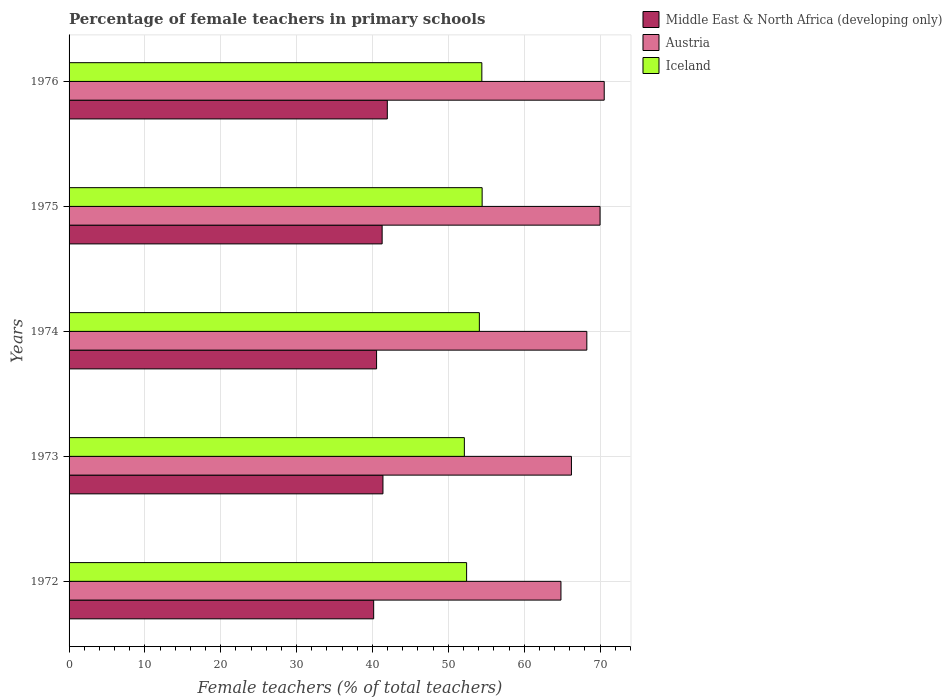How many different coloured bars are there?
Ensure brevity in your answer.  3. Are the number of bars on each tick of the Y-axis equal?
Keep it short and to the point. Yes. How many bars are there on the 1st tick from the top?
Provide a short and direct response. 3. What is the label of the 3rd group of bars from the top?
Offer a very short reply. 1974. What is the percentage of female teachers in Austria in 1976?
Keep it short and to the point. 70.55. Across all years, what is the maximum percentage of female teachers in Middle East & North Africa (developing only)?
Offer a terse response. 41.96. Across all years, what is the minimum percentage of female teachers in Iceland?
Give a very brief answer. 52.11. In which year was the percentage of female teachers in Iceland maximum?
Your answer should be compact. 1975. What is the total percentage of female teachers in Iceland in the graph?
Provide a short and direct response. 267.5. What is the difference between the percentage of female teachers in Austria in 1974 and that in 1975?
Provide a short and direct response. -1.74. What is the difference between the percentage of female teachers in Middle East & North Africa (developing only) in 1976 and the percentage of female teachers in Iceland in 1972?
Give a very brief answer. -10.45. What is the average percentage of female teachers in Austria per year?
Your answer should be very brief. 67.98. In the year 1976, what is the difference between the percentage of female teachers in Austria and percentage of female teachers in Iceland?
Make the answer very short. 16.13. In how many years, is the percentage of female teachers in Iceland greater than 12 %?
Give a very brief answer. 5. What is the ratio of the percentage of female teachers in Middle East & North Africa (developing only) in 1972 to that in 1974?
Give a very brief answer. 0.99. Is the percentage of female teachers in Iceland in 1972 less than that in 1974?
Offer a terse response. Yes. Is the difference between the percentage of female teachers in Austria in 1973 and 1975 greater than the difference between the percentage of female teachers in Iceland in 1973 and 1975?
Provide a succinct answer. No. What is the difference between the highest and the second highest percentage of female teachers in Middle East & North Africa (developing only)?
Keep it short and to the point. 0.57. What is the difference between the highest and the lowest percentage of female teachers in Austria?
Give a very brief answer. 5.7. In how many years, is the percentage of female teachers in Iceland greater than the average percentage of female teachers in Iceland taken over all years?
Make the answer very short. 3. Is the sum of the percentage of female teachers in Middle East & North Africa (developing only) in 1972 and 1976 greater than the maximum percentage of female teachers in Iceland across all years?
Your answer should be very brief. Yes. What does the 3rd bar from the top in 1974 represents?
Your answer should be compact. Middle East & North Africa (developing only). What does the 2nd bar from the bottom in 1972 represents?
Your answer should be compact. Austria. How many bars are there?
Offer a terse response. 15. What is the difference between two consecutive major ticks on the X-axis?
Your answer should be very brief. 10. Are the values on the major ticks of X-axis written in scientific E-notation?
Your answer should be compact. No. Where does the legend appear in the graph?
Give a very brief answer. Top right. What is the title of the graph?
Offer a very short reply. Percentage of female teachers in primary schools. What is the label or title of the X-axis?
Make the answer very short. Female teachers (% of total teachers). What is the Female teachers (% of total teachers) of Middle East & North Africa (developing only) in 1972?
Your response must be concise. 40.16. What is the Female teachers (% of total teachers) of Austria in 1972?
Offer a terse response. 64.85. What is the Female teachers (% of total teachers) in Iceland in 1972?
Ensure brevity in your answer.  52.41. What is the Female teachers (% of total teachers) of Middle East & North Africa (developing only) in 1973?
Keep it short and to the point. 41.38. What is the Female teachers (% of total teachers) in Austria in 1973?
Your answer should be compact. 66.23. What is the Female teachers (% of total teachers) of Iceland in 1973?
Provide a short and direct response. 52.11. What is the Female teachers (% of total teachers) in Middle East & North Africa (developing only) in 1974?
Offer a very short reply. 40.54. What is the Female teachers (% of total teachers) in Austria in 1974?
Give a very brief answer. 68.26. What is the Female teachers (% of total teachers) of Iceland in 1974?
Provide a short and direct response. 54.09. What is the Female teachers (% of total teachers) of Middle East & North Africa (developing only) in 1975?
Provide a succinct answer. 41.28. What is the Female teachers (% of total teachers) in Austria in 1975?
Offer a terse response. 70.01. What is the Female teachers (% of total teachers) of Iceland in 1975?
Your answer should be compact. 54.46. What is the Female teachers (% of total teachers) of Middle East & North Africa (developing only) in 1976?
Your response must be concise. 41.96. What is the Female teachers (% of total teachers) in Austria in 1976?
Make the answer very short. 70.55. What is the Female teachers (% of total teachers) of Iceland in 1976?
Ensure brevity in your answer.  54.42. Across all years, what is the maximum Female teachers (% of total teachers) in Middle East & North Africa (developing only)?
Offer a terse response. 41.96. Across all years, what is the maximum Female teachers (% of total teachers) in Austria?
Give a very brief answer. 70.55. Across all years, what is the maximum Female teachers (% of total teachers) in Iceland?
Your response must be concise. 54.46. Across all years, what is the minimum Female teachers (% of total teachers) of Middle East & North Africa (developing only)?
Your answer should be compact. 40.16. Across all years, what is the minimum Female teachers (% of total teachers) of Austria?
Ensure brevity in your answer.  64.85. Across all years, what is the minimum Female teachers (% of total teachers) of Iceland?
Ensure brevity in your answer.  52.11. What is the total Female teachers (% of total teachers) in Middle East & North Africa (developing only) in the graph?
Keep it short and to the point. 205.31. What is the total Female teachers (% of total teachers) of Austria in the graph?
Make the answer very short. 339.91. What is the total Female teachers (% of total teachers) in Iceland in the graph?
Provide a short and direct response. 267.5. What is the difference between the Female teachers (% of total teachers) of Middle East & North Africa (developing only) in 1972 and that in 1973?
Ensure brevity in your answer.  -1.22. What is the difference between the Female teachers (% of total teachers) of Austria in 1972 and that in 1973?
Keep it short and to the point. -1.38. What is the difference between the Female teachers (% of total teachers) of Iceland in 1972 and that in 1973?
Offer a very short reply. 0.3. What is the difference between the Female teachers (% of total teachers) of Middle East & North Africa (developing only) in 1972 and that in 1974?
Provide a succinct answer. -0.38. What is the difference between the Female teachers (% of total teachers) of Austria in 1972 and that in 1974?
Give a very brief answer. -3.41. What is the difference between the Female teachers (% of total teachers) of Iceland in 1972 and that in 1974?
Your response must be concise. -1.68. What is the difference between the Female teachers (% of total teachers) in Middle East & North Africa (developing only) in 1972 and that in 1975?
Offer a very short reply. -1.12. What is the difference between the Female teachers (% of total teachers) in Austria in 1972 and that in 1975?
Offer a terse response. -5.15. What is the difference between the Female teachers (% of total teachers) in Iceland in 1972 and that in 1975?
Ensure brevity in your answer.  -2.05. What is the difference between the Female teachers (% of total teachers) of Middle East & North Africa (developing only) in 1972 and that in 1976?
Ensure brevity in your answer.  -1.8. What is the difference between the Female teachers (% of total teachers) in Austria in 1972 and that in 1976?
Offer a very short reply. -5.7. What is the difference between the Female teachers (% of total teachers) of Iceland in 1972 and that in 1976?
Offer a terse response. -2.01. What is the difference between the Female teachers (% of total teachers) of Middle East & North Africa (developing only) in 1973 and that in 1974?
Offer a terse response. 0.84. What is the difference between the Female teachers (% of total teachers) of Austria in 1973 and that in 1974?
Offer a very short reply. -2.03. What is the difference between the Female teachers (% of total teachers) of Iceland in 1973 and that in 1974?
Your response must be concise. -1.98. What is the difference between the Female teachers (% of total teachers) in Middle East & North Africa (developing only) in 1973 and that in 1975?
Ensure brevity in your answer.  0.11. What is the difference between the Female teachers (% of total teachers) of Austria in 1973 and that in 1975?
Provide a succinct answer. -3.77. What is the difference between the Female teachers (% of total teachers) in Iceland in 1973 and that in 1975?
Your answer should be compact. -2.35. What is the difference between the Female teachers (% of total teachers) of Middle East & North Africa (developing only) in 1973 and that in 1976?
Ensure brevity in your answer.  -0.57. What is the difference between the Female teachers (% of total teachers) in Austria in 1973 and that in 1976?
Provide a short and direct response. -4.32. What is the difference between the Female teachers (% of total teachers) in Iceland in 1973 and that in 1976?
Your answer should be very brief. -2.31. What is the difference between the Female teachers (% of total teachers) in Middle East & North Africa (developing only) in 1974 and that in 1975?
Make the answer very short. -0.73. What is the difference between the Female teachers (% of total teachers) in Austria in 1974 and that in 1975?
Make the answer very short. -1.74. What is the difference between the Female teachers (% of total teachers) of Iceland in 1974 and that in 1975?
Offer a very short reply. -0.37. What is the difference between the Female teachers (% of total teachers) of Middle East & North Africa (developing only) in 1974 and that in 1976?
Provide a succinct answer. -1.42. What is the difference between the Female teachers (% of total teachers) in Austria in 1974 and that in 1976?
Provide a short and direct response. -2.29. What is the difference between the Female teachers (% of total teachers) of Iceland in 1974 and that in 1976?
Your answer should be compact. -0.33. What is the difference between the Female teachers (% of total teachers) of Middle East & North Africa (developing only) in 1975 and that in 1976?
Offer a very short reply. -0.68. What is the difference between the Female teachers (% of total teachers) of Austria in 1975 and that in 1976?
Make the answer very short. -0.55. What is the difference between the Female teachers (% of total teachers) in Iceland in 1975 and that in 1976?
Offer a terse response. 0.04. What is the difference between the Female teachers (% of total teachers) of Middle East & North Africa (developing only) in 1972 and the Female teachers (% of total teachers) of Austria in 1973?
Provide a short and direct response. -26.07. What is the difference between the Female teachers (% of total teachers) of Middle East & North Africa (developing only) in 1972 and the Female teachers (% of total teachers) of Iceland in 1973?
Your response must be concise. -11.96. What is the difference between the Female teachers (% of total teachers) in Austria in 1972 and the Female teachers (% of total teachers) in Iceland in 1973?
Your answer should be compact. 12.74. What is the difference between the Female teachers (% of total teachers) of Middle East & North Africa (developing only) in 1972 and the Female teachers (% of total teachers) of Austria in 1974?
Ensure brevity in your answer.  -28.1. What is the difference between the Female teachers (% of total teachers) in Middle East & North Africa (developing only) in 1972 and the Female teachers (% of total teachers) in Iceland in 1974?
Provide a short and direct response. -13.93. What is the difference between the Female teachers (% of total teachers) of Austria in 1972 and the Female teachers (% of total teachers) of Iceland in 1974?
Your answer should be very brief. 10.76. What is the difference between the Female teachers (% of total teachers) in Middle East & North Africa (developing only) in 1972 and the Female teachers (% of total teachers) in Austria in 1975?
Provide a succinct answer. -29.85. What is the difference between the Female teachers (% of total teachers) in Middle East & North Africa (developing only) in 1972 and the Female teachers (% of total teachers) in Iceland in 1975?
Your answer should be compact. -14.3. What is the difference between the Female teachers (% of total teachers) of Austria in 1972 and the Female teachers (% of total teachers) of Iceland in 1975?
Ensure brevity in your answer.  10.39. What is the difference between the Female teachers (% of total teachers) of Middle East & North Africa (developing only) in 1972 and the Female teachers (% of total teachers) of Austria in 1976?
Keep it short and to the point. -30.39. What is the difference between the Female teachers (% of total teachers) of Middle East & North Africa (developing only) in 1972 and the Female teachers (% of total teachers) of Iceland in 1976?
Offer a very short reply. -14.26. What is the difference between the Female teachers (% of total teachers) in Austria in 1972 and the Female teachers (% of total teachers) in Iceland in 1976?
Offer a terse response. 10.43. What is the difference between the Female teachers (% of total teachers) in Middle East & North Africa (developing only) in 1973 and the Female teachers (% of total teachers) in Austria in 1974?
Your response must be concise. -26.88. What is the difference between the Female teachers (% of total teachers) of Middle East & North Africa (developing only) in 1973 and the Female teachers (% of total teachers) of Iceland in 1974?
Your answer should be compact. -12.71. What is the difference between the Female teachers (% of total teachers) of Austria in 1973 and the Female teachers (% of total teachers) of Iceland in 1974?
Provide a succinct answer. 12.14. What is the difference between the Female teachers (% of total teachers) in Middle East & North Africa (developing only) in 1973 and the Female teachers (% of total teachers) in Austria in 1975?
Your response must be concise. -28.62. What is the difference between the Female teachers (% of total teachers) of Middle East & North Africa (developing only) in 1973 and the Female teachers (% of total teachers) of Iceland in 1975?
Offer a very short reply. -13.08. What is the difference between the Female teachers (% of total teachers) of Austria in 1973 and the Female teachers (% of total teachers) of Iceland in 1975?
Provide a succinct answer. 11.77. What is the difference between the Female teachers (% of total teachers) of Middle East & North Africa (developing only) in 1973 and the Female teachers (% of total teachers) of Austria in 1976?
Make the answer very short. -29.17. What is the difference between the Female teachers (% of total teachers) of Middle East & North Africa (developing only) in 1973 and the Female teachers (% of total teachers) of Iceland in 1976?
Make the answer very short. -13.04. What is the difference between the Female teachers (% of total teachers) in Austria in 1973 and the Female teachers (% of total teachers) in Iceland in 1976?
Your response must be concise. 11.81. What is the difference between the Female teachers (% of total teachers) in Middle East & North Africa (developing only) in 1974 and the Female teachers (% of total teachers) in Austria in 1975?
Your answer should be very brief. -29.46. What is the difference between the Female teachers (% of total teachers) in Middle East & North Africa (developing only) in 1974 and the Female teachers (% of total teachers) in Iceland in 1975?
Your response must be concise. -13.92. What is the difference between the Female teachers (% of total teachers) of Austria in 1974 and the Female teachers (% of total teachers) of Iceland in 1975?
Your response must be concise. 13.8. What is the difference between the Female teachers (% of total teachers) in Middle East & North Africa (developing only) in 1974 and the Female teachers (% of total teachers) in Austria in 1976?
Provide a succinct answer. -30.01. What is the difference between the Female teachers (% of total teachers) of Middle East & North Africa (developing only) in 1974 and the Female teachers (% of total teachers) of Iceland in 1976?
Make the answer very short. -13.88. What is the difference between the Female teachers (% of total teachers) in Austria in 1974 and the Female teachers (% of total teachers) in Iceland in 1976?
Make the answer very short. 13.84. What is the difference between the Female teachers (% of total teachers) in Middle East & North Africa (developing only) in 1975 and the Female teachers (% of total teachers) in Austria in 1976?
Keep it short and to the point. -29.28. What is the difference between the Female teachers (% of total teachers) of Middle East & North Africa (developing only) in 1975 and the Female teachers (% of total teachers) of Iceland in 1976?
Provide a short and direct response. -13.14. What is the difference between the Female teachers (% of total teachers) of Austria in 1975 and the Female teachers (% of total teachers) of Iceland in 1976?
Your answer should be very brief. 15.59. What is the average Female teachers (% of total teachers) in Middle East & North Africa (developing only) per year?
Give a very brief answer. 41.06. What is the average Female teachers (% of total teachers) of Austria per year?
Make the answer very short. 67.98. What is the average Female teachers (% of total teachers) of Iceland per year?
Your answer should be compact. 53.5. In the year 1972, what is the difference between the Female teachers (% of total teachers) in Middle East & North Africa (developing only) and Female teachers (% of total teachers) in Austria?
Keep it short and to the point. -24.69. In the year 1972, what is the difference between the Female teachers (% of total teachers) in Middle East & North Africa (developing only) and Female teachers (% of total teachers) in Iceland?
Ensure brevity in your answer.  -12.25. In the year 1972, what is the difference between the Female teachers (% of total teachers) of Austria and Female teachers (% of total teachers) of Iceland?
Your answer should be very brief. 12.44. In the year 1973, what is the difference between the Female teachers (% of total teachers) of Middle East & North Africa (developing only) and Female teachers (% of total teachers) of Austria?
Give a very brief answer. -24.85. In the year 1973, what is the difference between the Female teachers (% of total teachers) in Middle East & North Africa (developing only) and Female teachers (% of total teachers) in Iceland?
Your answer should be very brief. -10.73. In the year 1973, what is the difference between the Female teachers (% of total teachers) in Austria and Female teachers (% of total teachers) in Iceland?
Your answer should be very brief. 14.12. In the year 1974, what is the difference between the Female teachers (% of total teachers) of Middle East & North Africa (developing only) and Female teachers (% of total teachers) of Austria?
Give a very brief answer. -27.72. In the year 1974, what is the difference between the Female teachers (% of total teachers) of Middle East & North Africa (developing only) and Female teachers (% of total teachers) of Iceland?
Keep it short and to the point. -13.55. In the year 1974, what is the difference between the Female teachers (% of total teachers) in Austria and Female teachers (% of total teachers) in Iceland?
Your answer should be very brief. 14.17. In the year 1975, what is the difference between the Female teachers (% of total teachers) in Middle East & North Africa (developing only) and Female teachers (% of total teachers) in Austria?
Ensure brevity in your answer.  -28.73. In the year 1975, what is the difference between the Female teachers (% of total teachers) of Middle East & North Africa (developing only) and Female teachers (% of total teachers) of Iceland?
Offer a terse response. -13.18. In the year 1975, what is the difference between the Female teachers (% of total teachers) of Austria and Female teachers (% of total teachers) of Iceland?
Offer a terse response. 15.55. In the year 1976, what is the difference between the Female teachers (% of total teachers) of Middle East & North Africa (developing only) and Female teachers (% of total teachers) of Austria?
Your answer should be compact. -28.6. In the year 1976, what is the difference between the Female teachers (% of total teachers) in Middle East & North Africa (developing only) and Female teachers (% of total teachers) in Iceland?
Provide a succinct answer. -12.46. In the year 1976, what is the difference between the Female teachers (% of total teachers) in Austria and Female teachers (% of total teachers) in Iceland?
Provide a succinct answer. 16.13. What is the ratio of the Female teachers (% of total teachers) of Middle East & North Africa (developing only) in 1972 to that in 1973?
Offer a terse response. 0.97. What is the ratio of the Female teachers (% of total teachers) of Austria in 1972 to that in 1973?
Make the answer very short. 0.98. What is the ratio of the Female teachers (% of total teachers) of Middle East & North Africa (developing only) in 1972 to that in 1974?
Keep it short and to the point. 0.99. What is the ratio of the Female teachers (% of total teachers) in Iceland in 1972 to that in 1974?
Provide a short and direct response. 0.97. What is the ratio of the Female teachers (% of total teachers) in Middle East & North Africa (developing only) in 1972 to that in 1975?
Make the answer very short. 0.97. What is the ratio of the Female teachers (% of total teachers) of Austria in 1972 to that in 1975?
Keep it short and to the point. 0.93. What is the ratio of the Female teachers (% of total teachers) of Iceland in 1972 to that in 1975?
Keep it short and to the point. 0.96. What is the ratio of the Female teachers (% of total teachers) in Middle East & North Africa (developing only) in 1972 to that in 1976?
Your answer should be very brief. 0.96. What is the ratio of the Female teachers (% of total teachers) in Austria in 1972 to that in 1976?
Keep it short and to the point. 0.92. What is the ratio of the Female teachers (% of total teachers) in Iceland in 1972 to that in 1976?
Your response must be concise. 0.96. What is the ratio of the Female teachers (% of total teachers) in Middle East & North Africa (developing only) in 1973 to that in 1974?
Provide a succinct answer. 1.02. What is the ratio of the Female teachers (% of total teachers) in Austria in 1973 to that in 1974?
Give a very brief answer. 0.97. What is the ratio of the Female teachers (% of total teachers) of Iceland in 1973 to that in 1974?
Your response must be concise. 0.96. What is the ratio of the Female teachers (% of total teachers) in Middle East & North Africa (developing only) in 1973 to that in 1975?
Provide a succinct answer. 1. What is the ratio of the Female teachers (% of total teachers) of Austria in 1973 to that in 1975?
Your answer should be very brief. 0.95. What is the ratio of the Female teachers (% of total teachers) of Iceland in 1973 to that in 1975?
Make the answer very short. 0.96. What is the ratio of the Female teachers (% of total teachers) of Middle East & North Africa (developing only) in 1973 to that in 1976?
Give a very brief answer. 0.99. What is the ratio of the Female teachers (% of total teachers) of Austria in 1973 to that in 1976?
Your response must be concise. 0.94. What is the ratio of the Female teachers (% of total teachers) of Iceland in 1973 to that in 1976?
Offer a terse response. 0.96. What is the ratio of the Female teachers (% of total teachers) of Middle East & North Africa (developing only) in 1974 to that in 1975?
Offer a very short reply. 0.98. What is the ratio of the Female teachers (% of total teachers) of Austria in 1974 to that in 1975?
Ensure brevity in your answer.  0.98. What is the ratio of the Female teachers (% of total teachers) in Middle East & North Africa (developing only) in 1974 to that in 1976?
Your answer should be compact. 0.97. What is the ratio of the Female teachers (% of total teachers) of Austria in 1974 to that in 1976?
Make the answer very short. 0.97. What is the ratio of the Female teachers (% of total teachers) in Middle East & North Africa (developing only) in 1975 to that in 1976?
Your answer should be very brief. 0.98. What is the ratio of the Female teachers (% of total teachers) in Iceland in 1975 to that in 1976?
Your answer should be very brief. 1. What is the difference between the highest and the second highest Female teachers (% of total teachers) of Middle East & North Africa (developing only)?
Keep it short and to the point. 0.57. What is the difference between the highest and the second highest Female teachers (% of total teachers) in Austria?
Offer a terse response. 0.55. What is the difference between the highest and the second highest Female teachers (% of total teachers) of Iceland?
Your response must be concise. 0.04. What is the difference between the highest and the lowest Female teachers (% of total teachers) of Middle East & North Africa (developing only)?
Offer a very short reply. 1.8. What is the difference between the highest and the lowest Female teachers (% of total teachers) of Austria?
Offer a very short reply. 5.7. What is the difference between the highest and the lowest Female teachers (% of total teachers) of Iceland?
Provide a short and direct response. 2.35. 